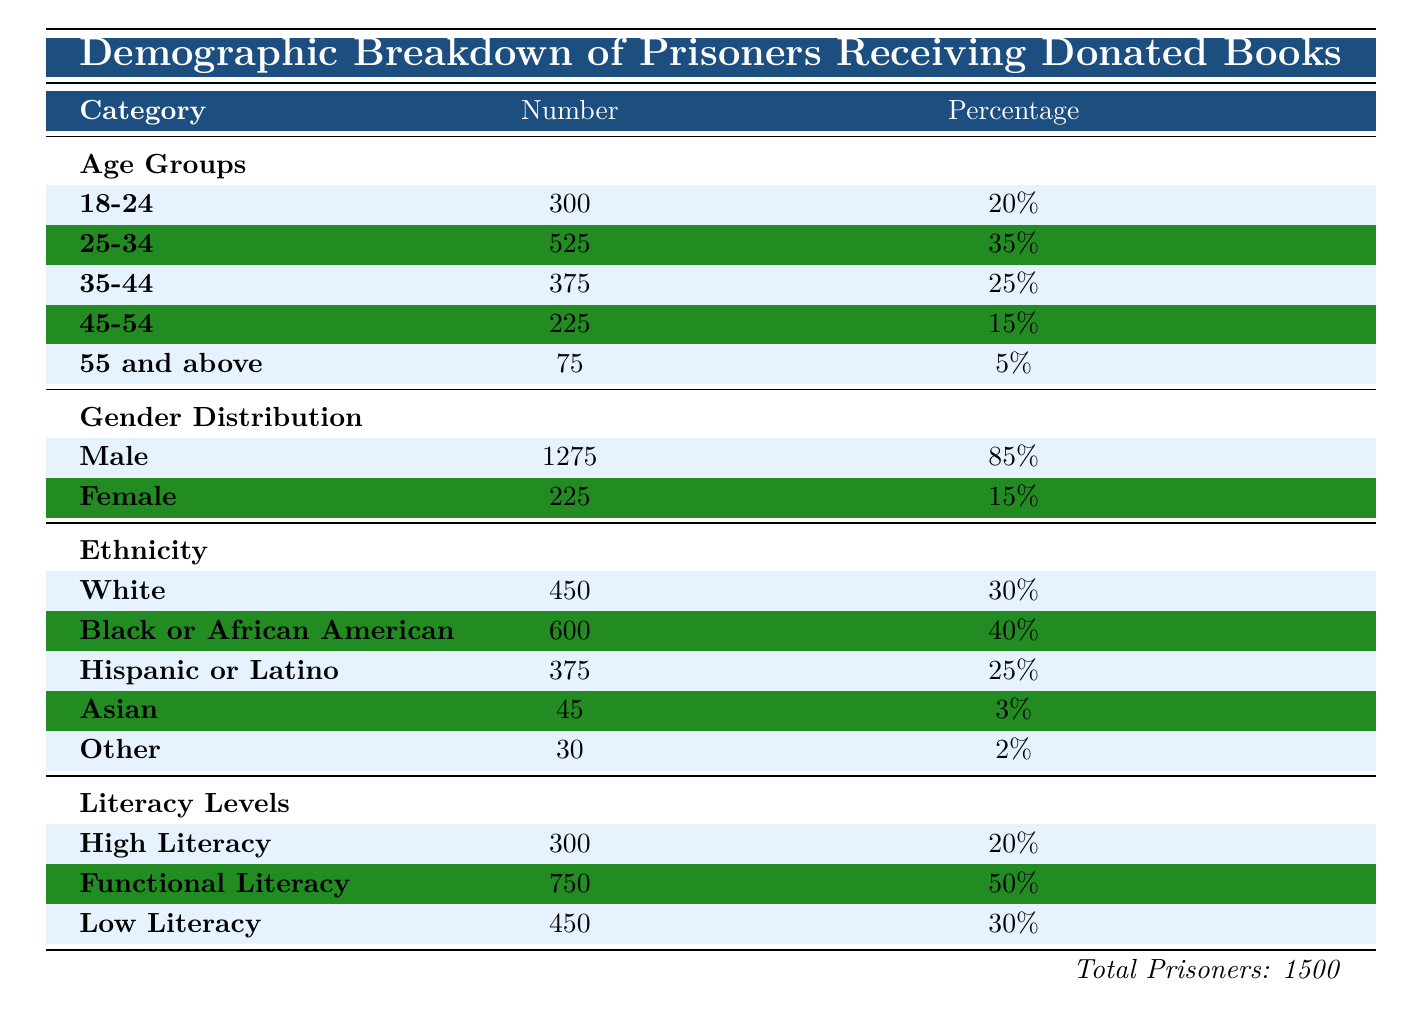What percentage of prisoners are in the 25-34 age group? The table indicates that the 25-34 age group constitutes 35% of the total prisoner population.
Answer: 35% How many male prisoners received donated books? According to the gender distribution section of the table, there are 1,275 male prisoners.
Answer: 1275 What is the total number of prisoners with Low Literacy levels? The table states that there are 450 prisoners categorized under Low Literacy levels.
Answer: 450 Is the percentage of Black or African American prisoners higher than Hispanic or Latino prisoners? The table lists the percentage of Black or African American prisoners as 40%, while that of Hispanic or Latino prisoners is 25%. Since 40% is greater than 25%, the statement is true.
Answer: Yes What is the combined number of prisoners aged 45 and above? The age groups for 45-54 and 55 and above indicate there are 225 and 75 prisoners, respectively. Adding these two groups gives us 225 + 75 = 300 prisoners aged 45 and above.
Answer: 300 How many prisoners fall within the age range of 18-34? The table shows that there are 300 prisoners in the 18-24 age group and 525 prisoners in the 25-34 age group. The total is 300 + 525 = 825 prisoners aged between 18 and 34.
Answer: 825 What proportion of the total prisoner population has High Literacy levels? The number of prisoners with High Literacy is 300 out of a total of 1,500 prisoners. To find the proportion, divide 300 by 1,500, which gives us 300/1500 = 0.2 or 20%.
Answer: 20% How many prisoners belong to the 'Other' ethnic group? The table identifies that there are 30 prisoners classified as belonging to the 'Other' ethnic group.
Answer: 30 Are there more prisoners with Functional Literacy than those with High Literacy? The table shows that 750 prisoners have Functional Literacy, while only 300 have High Literacy. Since 750 is greater than 300, this statement is true.
Answer: Yes 